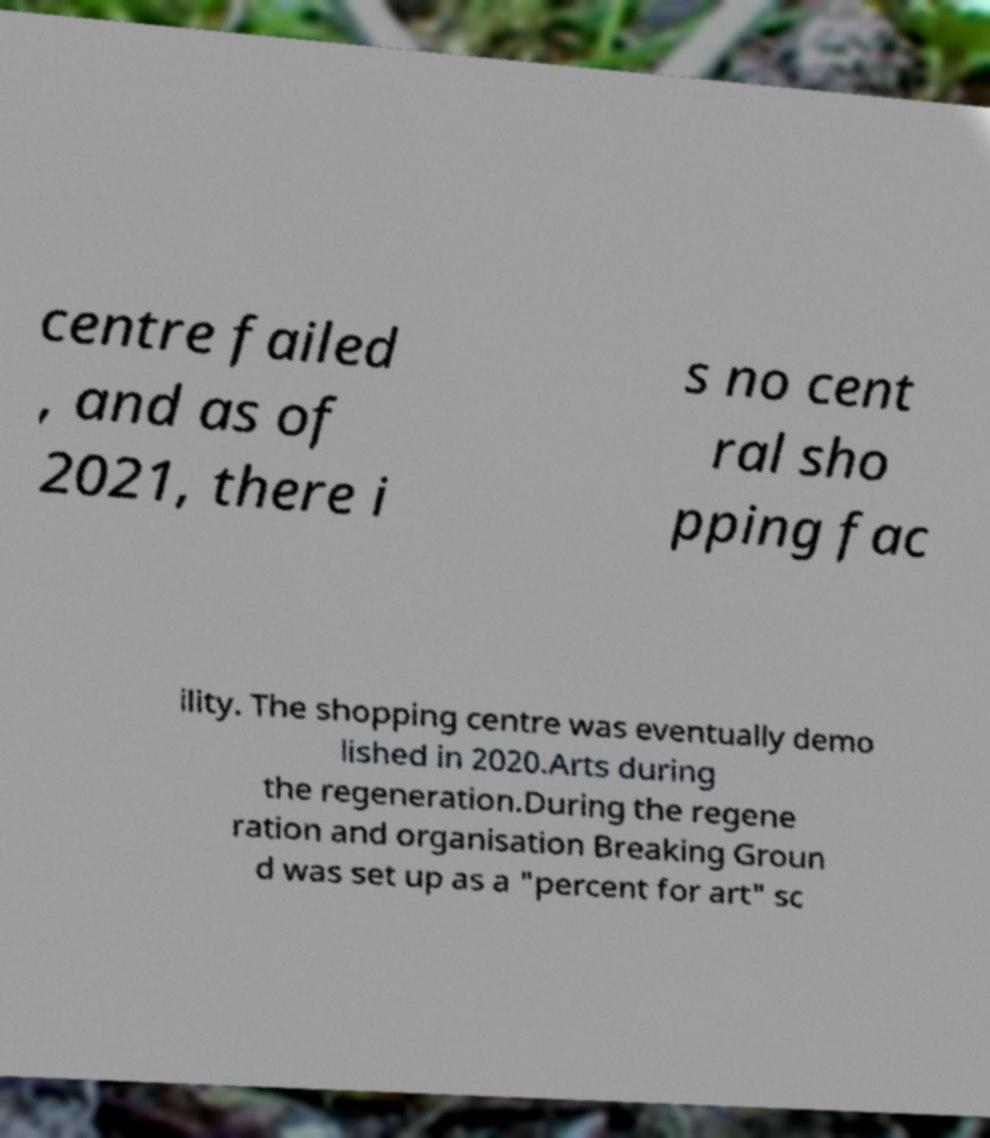I need the written content from this picture converted into text. Can you do that? centre failed , and as of 2021, there i s no cent ral sho pping fac ility. The shopping centre was eventually demo lished in 2020.Arts during the regeneration.During the regene ration and organisation Breaking Groun d was set up as a "percent for art" sc 